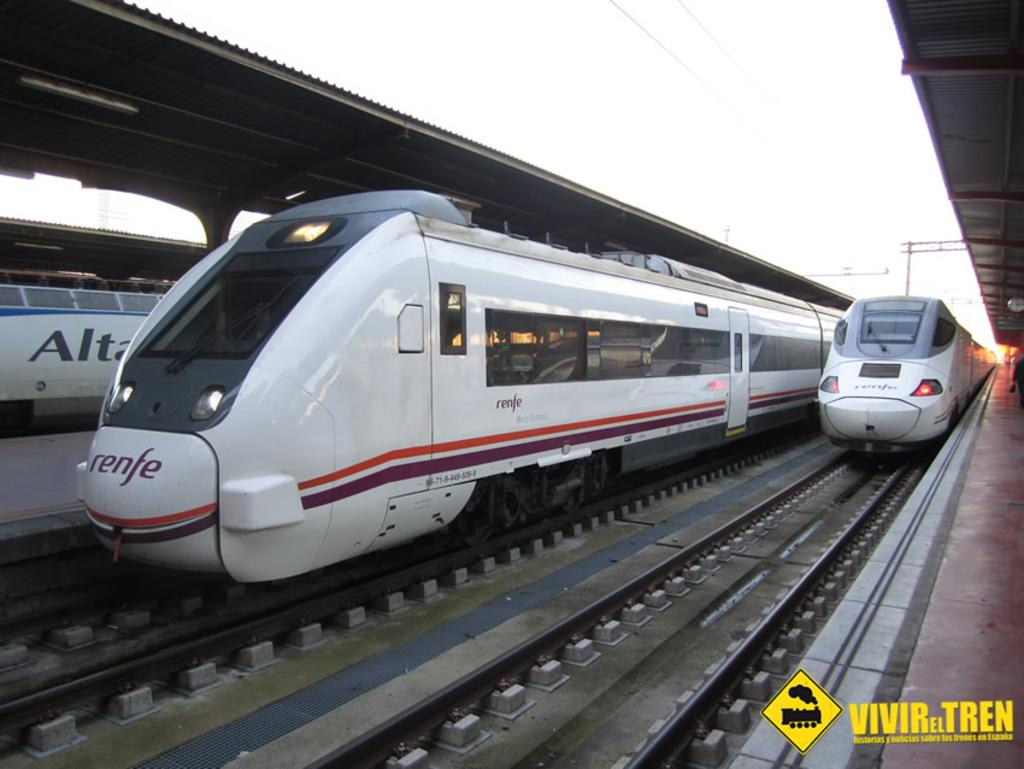What type of vehicles are present in the image? There are trains in the image. What color are the trains? The trains are white in color. What can be seen at the bottom of the image? There are tracks visible at the bottom of the image. What structure is on the right side of the image? There is a platform on the right side of the image. What is located at the top of the image? There are sheds at the top of the image, and the sky is also visible. Where is the bulb located in the image? There is no bulb present in the image. What type of cannon is being fired on the platform? There is no cannon present in the image, and no cannon is being fired. 